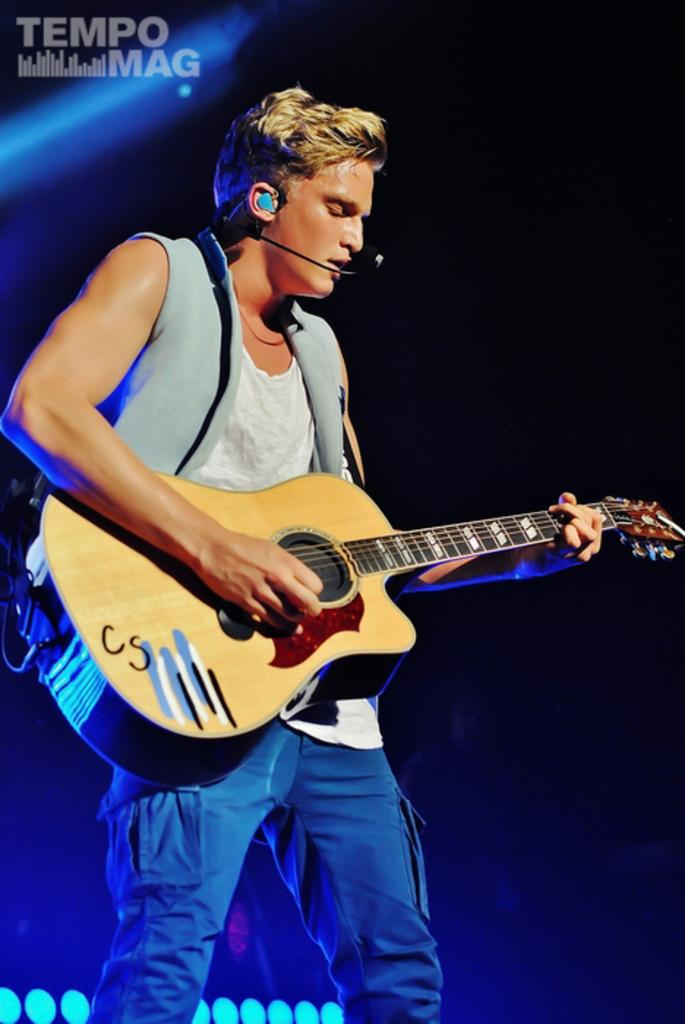Who is the main subject in the image? There is a man in the image. Where is the man positioned in the image? The man is towards the left side of the image. What is the man doing in the image? The man is playing a guitar and singing on a microphone. What colors are used in the background of the image? The background of the image is blue and black. Can you see any planes flying over the cemetery in the image? There is no cemetery or planes present in the image; it features a man playing a guitar and singing on a microphone with a blue and black background. 